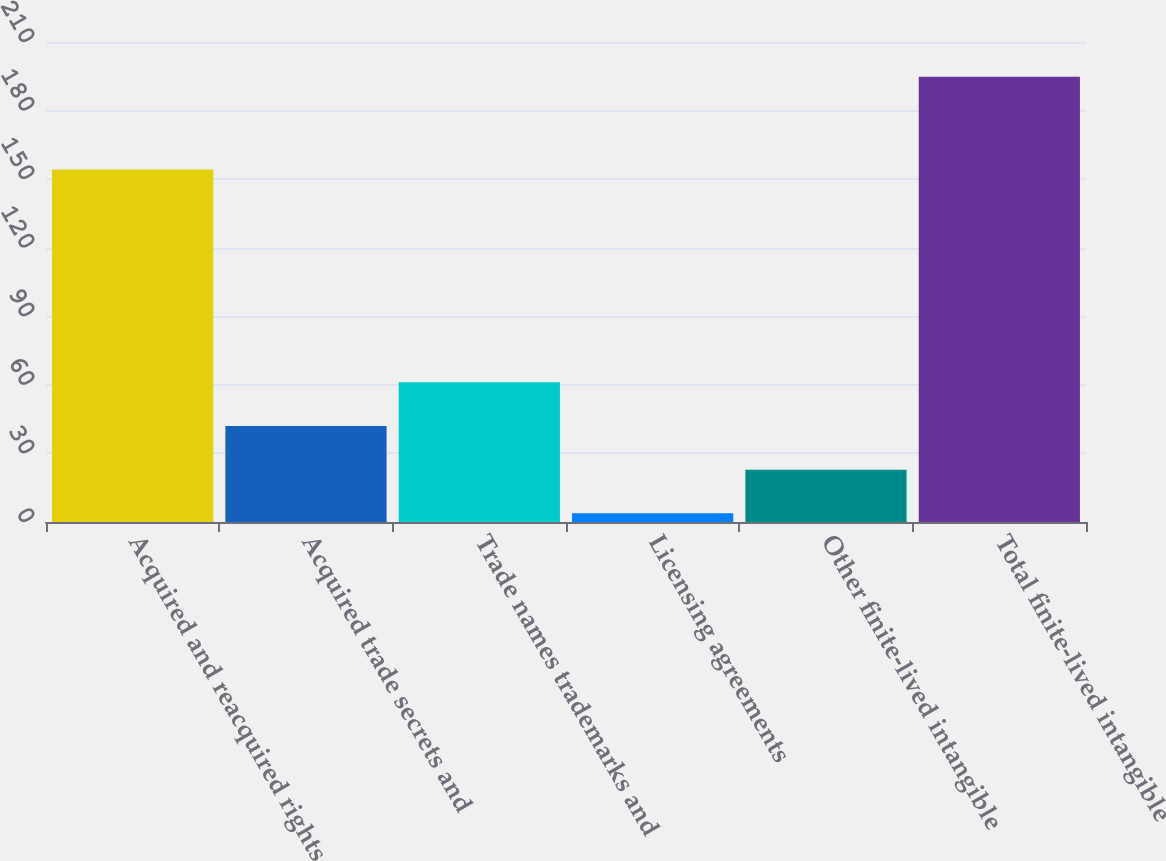<chart> <loc_0><loc_0><loc_500><loc_500><bar_chart><fcel>Acquired and reacquired rights<fcel>Acquired trade secrets and<fcel>Trade names trademarks and<fcel>Licensing agreements<fcel>Other finite-lived intangible<fcel>Total finite-lived intangible<nl><fcel>154.2<fcel>42<fcel>61.1<fcel>3.8<fcel>22.9<fcel>194.8<nl></chart> 